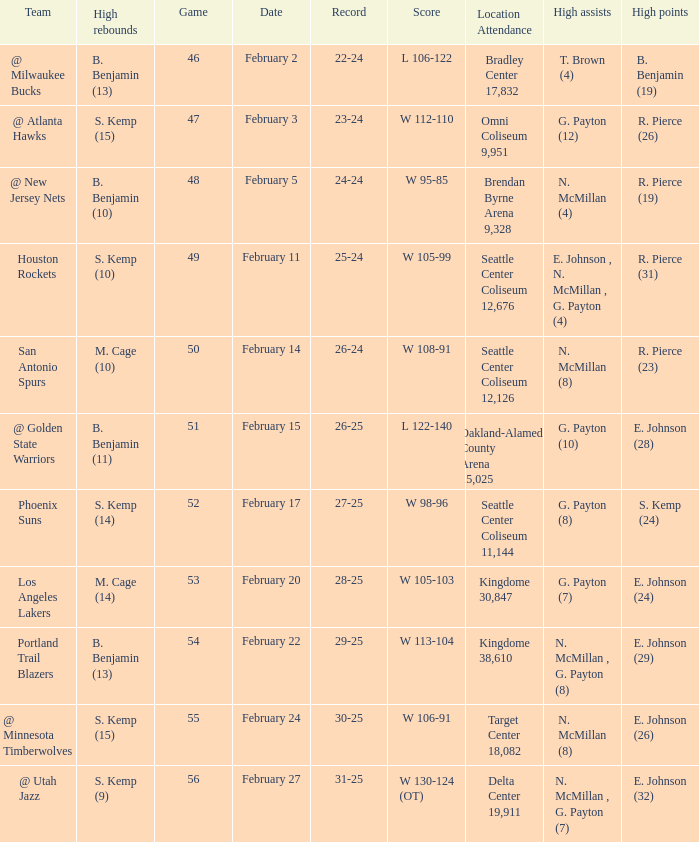What dated was the game played at the location delta center 19,911? February 27. 